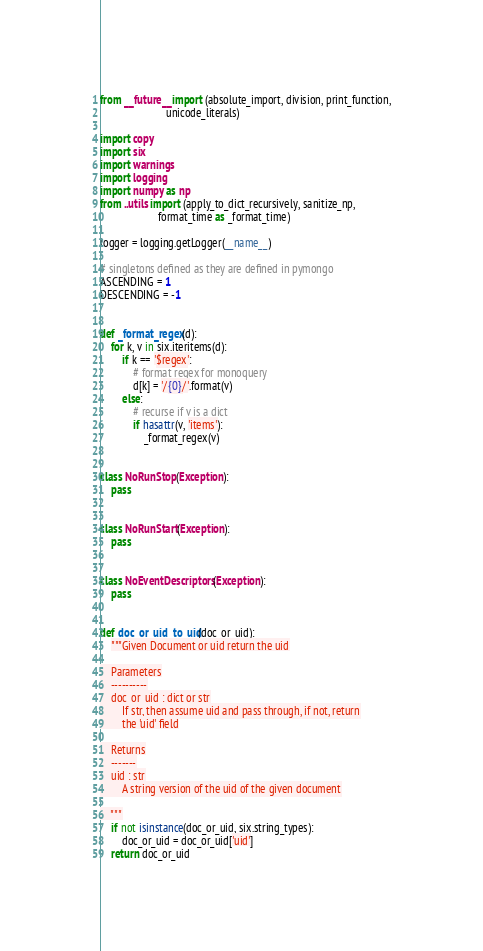Convert code to text. <code><loc_0><loc_0><loc_500><loc_500><_Python_>from __future__ import (absolute_import, division, print_function,
                        unicode_literals)

import copy
import six
import warnings
import logging
import numpy as np
from ..utils import (apply_to_dict_recursively, sanitize_np,
                     format_time as _format_time)

logger = logging.getLogger(__name__)

# singletons defined as they are defined in pymongo
ASCENDING = 1
DESCENDING = -1


def _format_regex(d):
    for k, v in six.iteritems(d):
        if k == '$regex':
            # format regex for monoquery
            d[k] = '/{0}/'.format(v)
        else:
            # recurse if v is a dict
            if hasattr(v, 'items'):
                _format_regex(v)


class NoRunStop(Exception):
    pass


class NoRunStart(Exception):
    pass


class NoEventDescriptors(Exception):
    pass


def doc_or_uid_to_uid(doc_or_uid):
    """Given Document or uid return the uid

    Parameters
    ----------
    doc_or_uid : dict or str
        If str, then assume uid and pass through, if not, return
        the 'uid' field

    Returns
    -------
    uid : str
        A string version of the uid of the given document

    """
    if not isinstance(doc_or_uid, six.string_types):
        doc_or_uid = doc_or_uid['uid']
    return doc_or_uid

</code> 